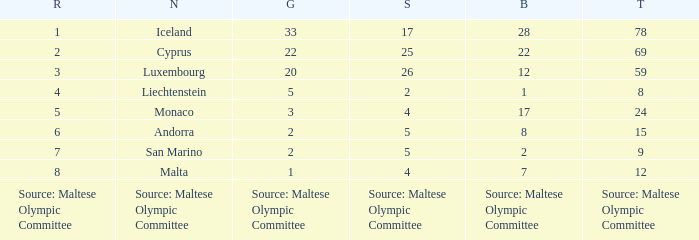What is the total medal count for the nation that has 5 gold? 8.0. 